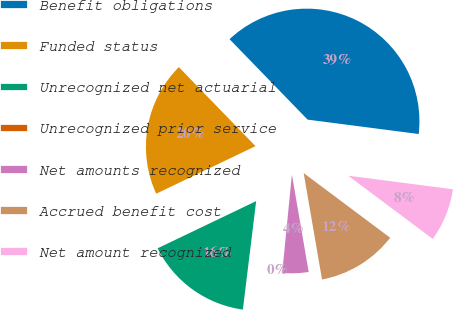Convert chart to OTSL. <chart><loc_0><loc_0><loc_500><loc_500><pie_chart><fcel>Benefit obligations<fcel>Funded status<fcel>Unrecognized net actuarial<fcel>Unrecognized prior service<fcel>Net amounts recognized<fcel>Accrued benefit cost<fcel>Net amount recognized<nl><fcel>39.31%<fcel>19.85%<fcel>15.95%<fcel>0.38%<fcel>4.28%<fcel>12.06%<fcel>8.17%<nl></chart> 